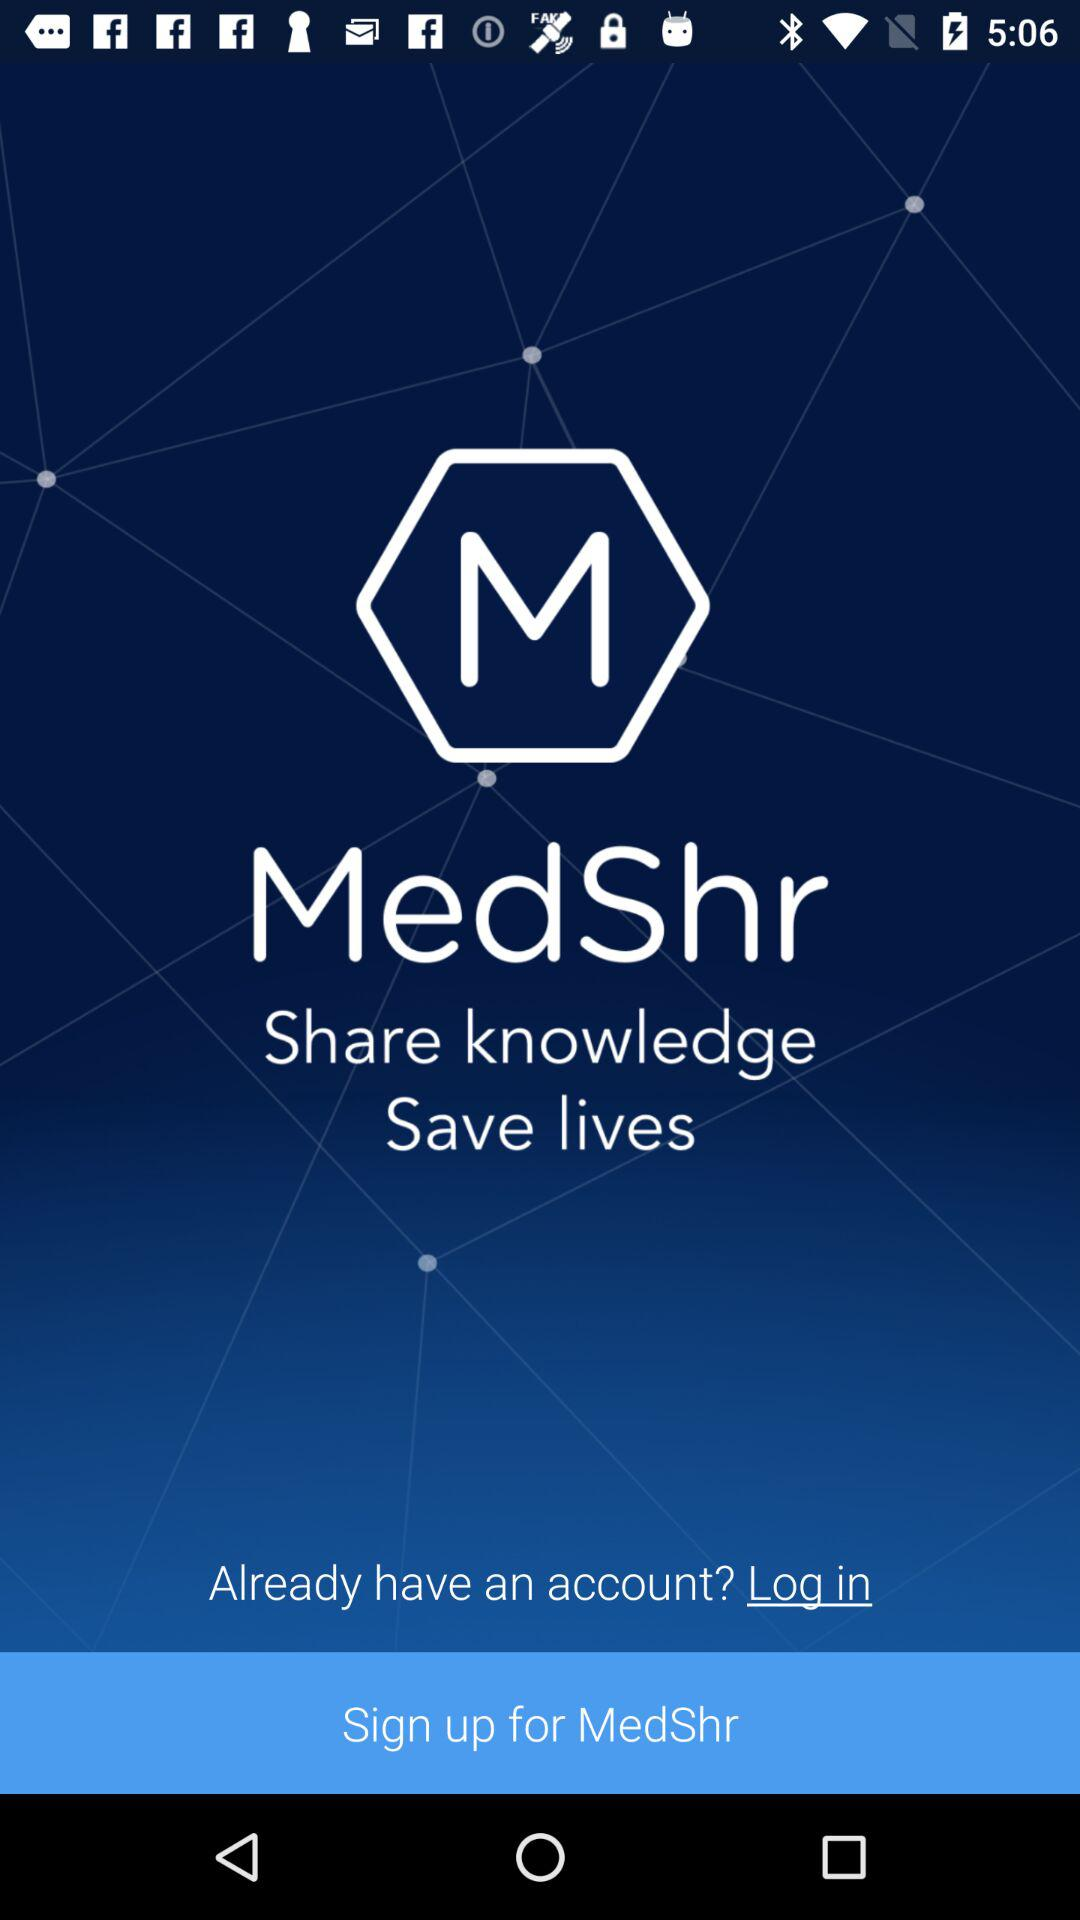Is a phone number required to sign up for "MedShr"?
When the provided information is insufficient, respond with <no answer>. <no answer> 